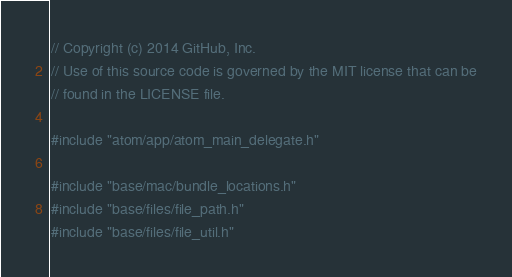Convert code to text. <code><loc_0><loc_0><loc_500><loc_500><_ObjectiveC_>// Copyright (c) 2014 GitHub, Inc.
// Use of this source code is governed by the MIT license that can be
// found in the LICENSE file.

#include "atom/app/atom_main_delegate.h"

#include "base/mac/bundle_locations.h"
#include "base/files/file_path.h"
#include "base/files/file_util.h"</code> 